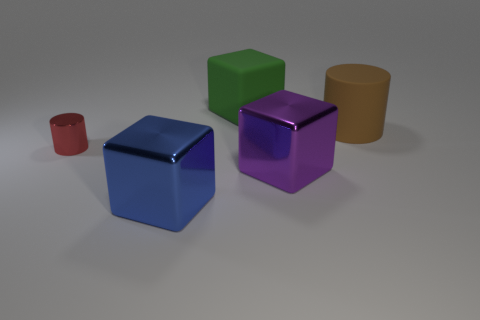Add 4 small cylinders. How many objects exist? 9 Subtract all blocks. How many objects are left? 2 Add 2 large blue objects. How many large blue objects are left? 3 Add 5 small blue cylinders. How many small blue cylinders exist? 5 Subtract 0 brown cubes. How many objects are left? 5 Subtract all large metal cylinders. Subtract all metal things. How many objects are left? 2 